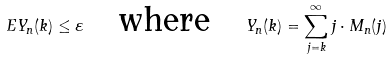Convert formula to latex. <formula><loc_0><loc_0><loc_500><loc_500>E Y _ { n } ( k ) \leq \varepsilon \quad \text {where} \quad Y _ { n } ( k ) = \sum _ { j = k } ^ { \infty } j \cdot M _ { n } ( j )</formula> 